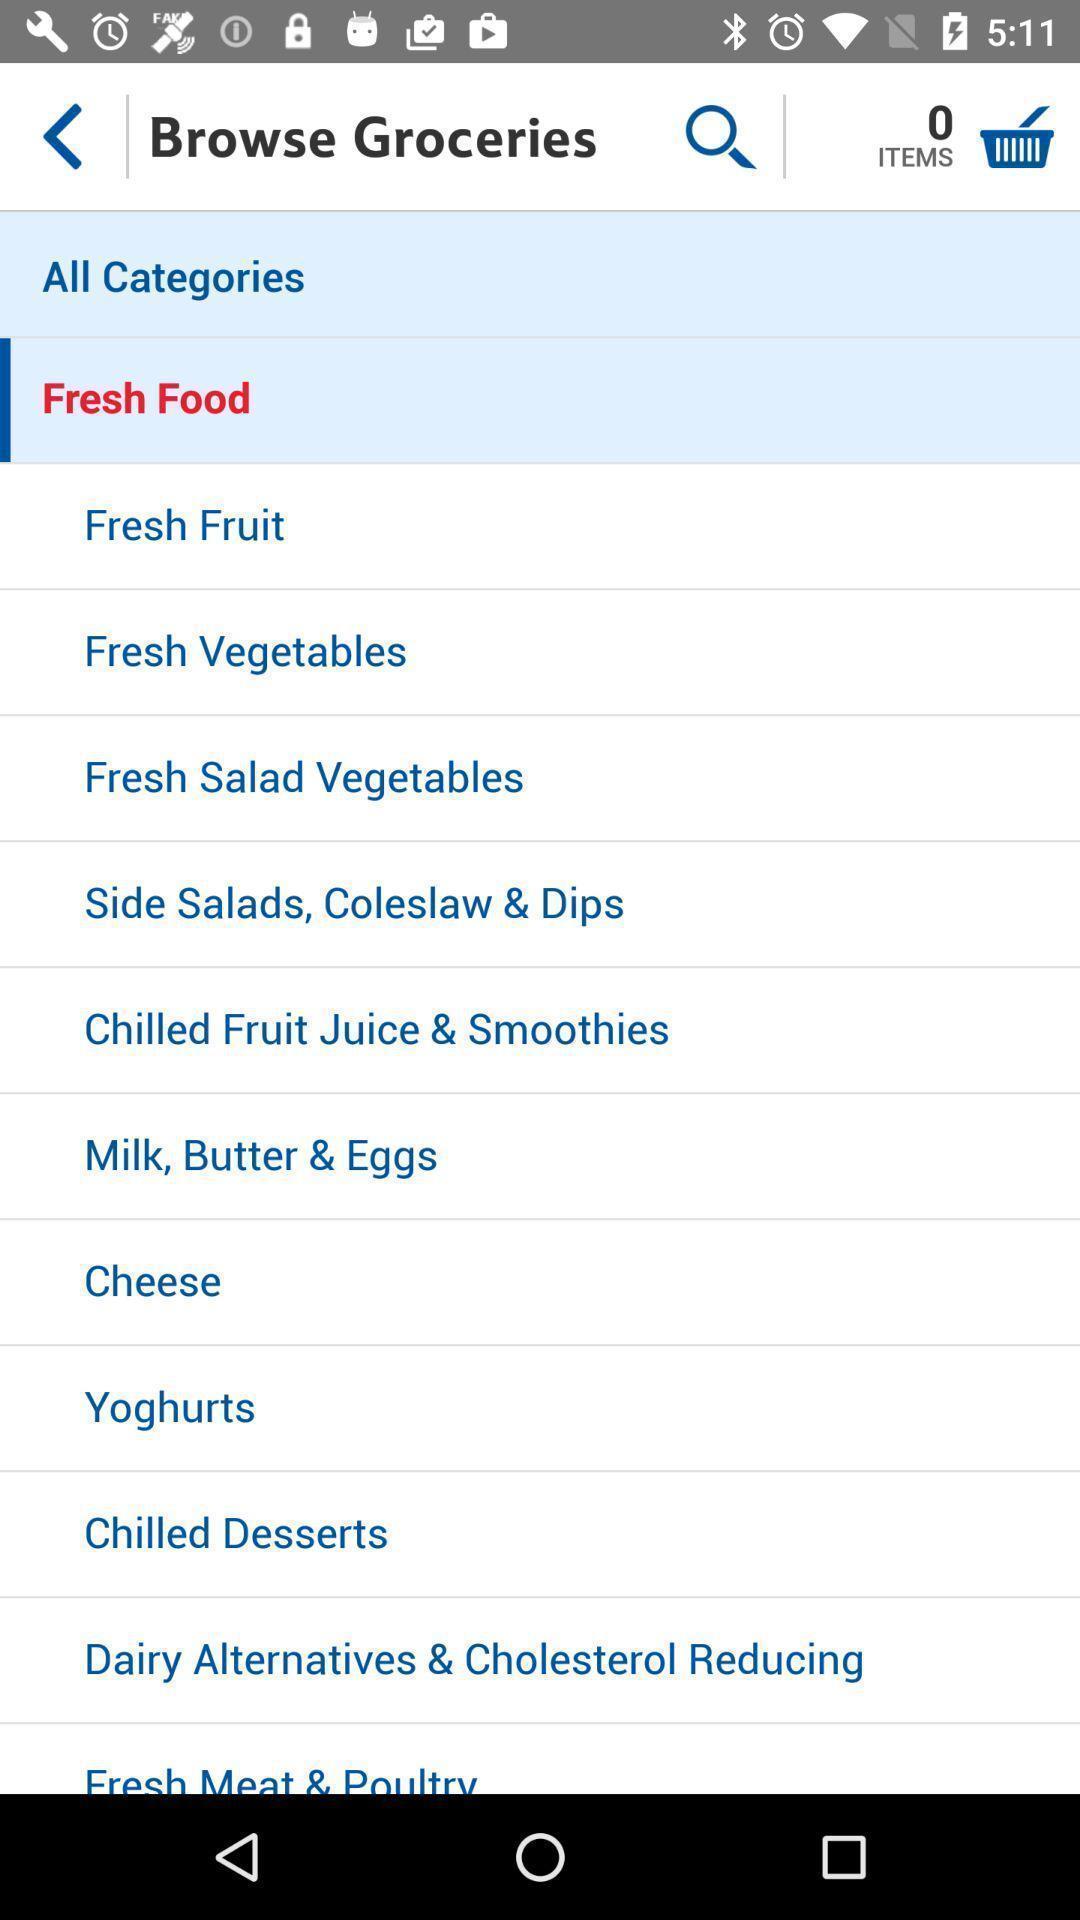Provide a textual representation of this image. Page shows groceries of shopping application. 